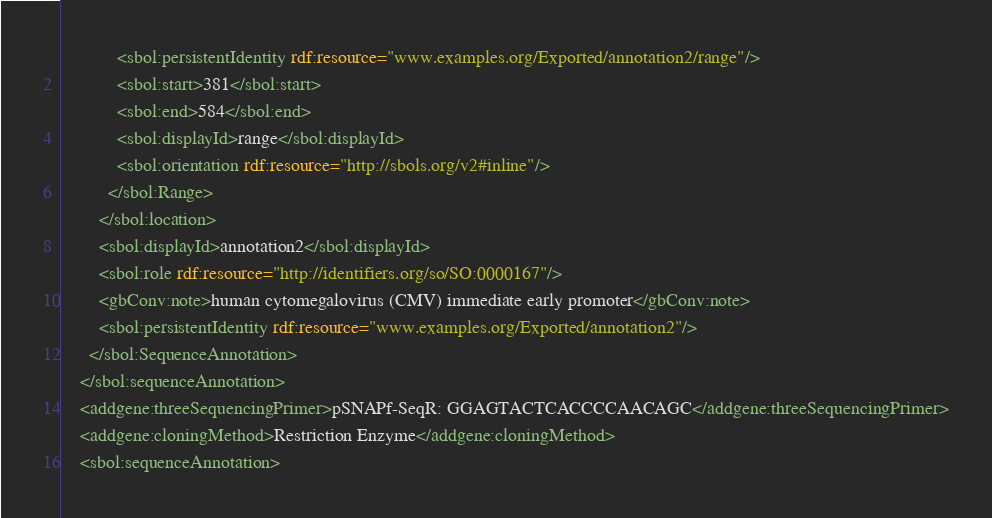Convert code to text. <code><loc_0><loc_0><loc_500><loc_500><_XML_>            <sbol:persistentIdentity rdf:resource="www.examples.org/Exported/annotation2/range"/>
            <sbol:start>381</sbol:start>
            <sbol:end>584</sbol:end>
            <sbol:displayId>range</sbol:displayId>
            <sbol:orientation rdf:resource="http://sbols.org/v2#inline"/>
          </sbol:Range>
        </sbol:location>
        <sbol:displayId>annotation2</sbol:displayId>
        <sbol:role rdf:resource="http://identifiers.org/so/SO:0000167"/>
        <gbConv:note>human cytomegalovirus (CMV) immediate early promoter</gbConv:note>
        <sbol:persistentIdentity rdf:resource="www.examples.org/Exported/annotation2"/>
      </sbol:SequenceAnnotation>
    </sbol:sequenceAnnotation>
    <addgene:threeSequencingPrimer>pSNAPf-SeqR: GGAGTACTCACCCCAACAGC</addgene:threeSequencingPrimer>
    <addgene:cloningMethod>Restriction Enzyme</addgene:cloningMethod>
    <sbol:sequenceAnnotation></code> 